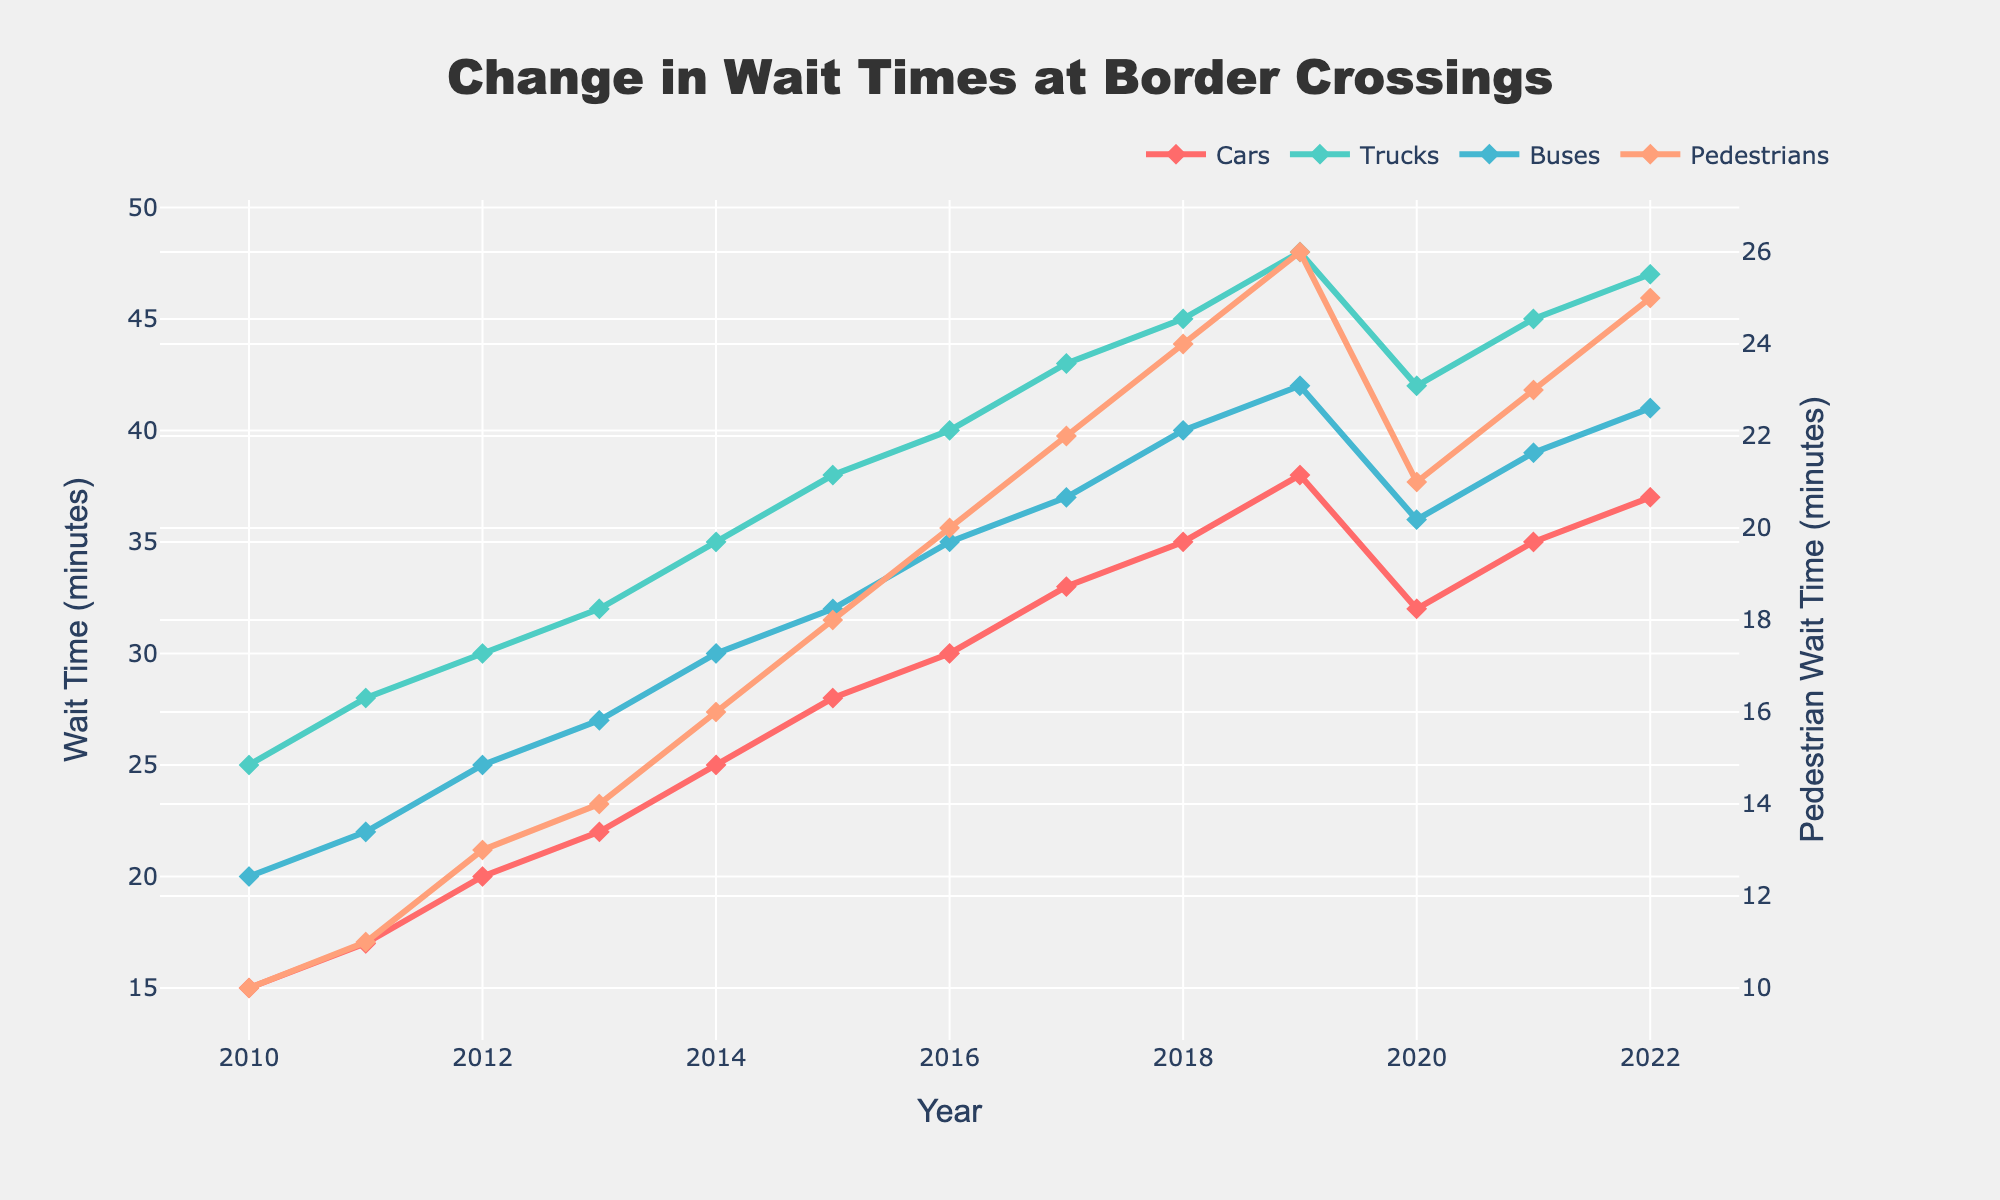What is the overall trend of wait times for cars between 2010 and 2022? To determine the overall trend, observe the line representing cars. From 2010 to 2022, the wait time for cars increases from 15 minutes to 37 minutes, indicating an upward trend.
Answer: Upward Which vehicle type had the highest wait time in 2019? Look at the peaks for each line in 2019. The wait times are: Cars - 38, Trucks - 48, Buses - 42, Pedestrians - 26. Trucks have the highest wait time.
Answer: Trucks How much did the wait time for buses increase from 2010 to 2012? The wait time for buses was 20 minutes in 2010 and increased to 25 minutes in 2012. The increase is 25 - 20 = 5 minutes.
Answer: 5 minutes What is the difference in wait times between trucks and pedestrians in 2020? In 2020, the wait time for trucks was 42 minutes and for pedestrians was 21 minutes. The difference is 42 - 21 = 21 minutes.
Answer: 21 minutes Which vehicle type consistently had the lowest wait times throughout the years? Observe all the lines and identify the one with the lowest values in general. The line for pedestrians is consistently the lowest.
Answer: Pedestrians What year did cars experience a rapid decrease in wait times? Look for a noticeable drop in the line for cars. There is a significant drop from 38 minutes in 2019 to 32 minutes in 2020.
Answer: 2020 Compare the wait times for trucks and buses in 2015. Which had a shorter wait time and by how much? In 2015, the wait time for trucks was 38 minutes and for buses was 32 minutes. Buses had a shorter wait time by 38 - 32 = 6 minutes.
Answer: Buses, 6 minutes What is the average wait time for pedestrians from 2010 to 2022? Add the wait times for pedestrians from 2010 (10 minutes) to 2022 (25 minutes) and divide by the number of years (13). (10+11+13+14+16+18+20+22+24+26+21+23+25)/13 = 18.38 minutes.
Answer: 18.38 minutes Which year did trucks reach a wait time of 45 minutes first? Locate the point at which the truck line first hits 45 minutes. This occurs in the year 2018.
Answer: 2018 How does the visual thickness of the lines help in understanding the data better? The visual thickness of the lines (and use of markers like diamonds) helps distinguish between vehicle types and makes the trends for each vehicle type clearer, improving readability and data interpretation.
Answer: Improves readability and trend identification 